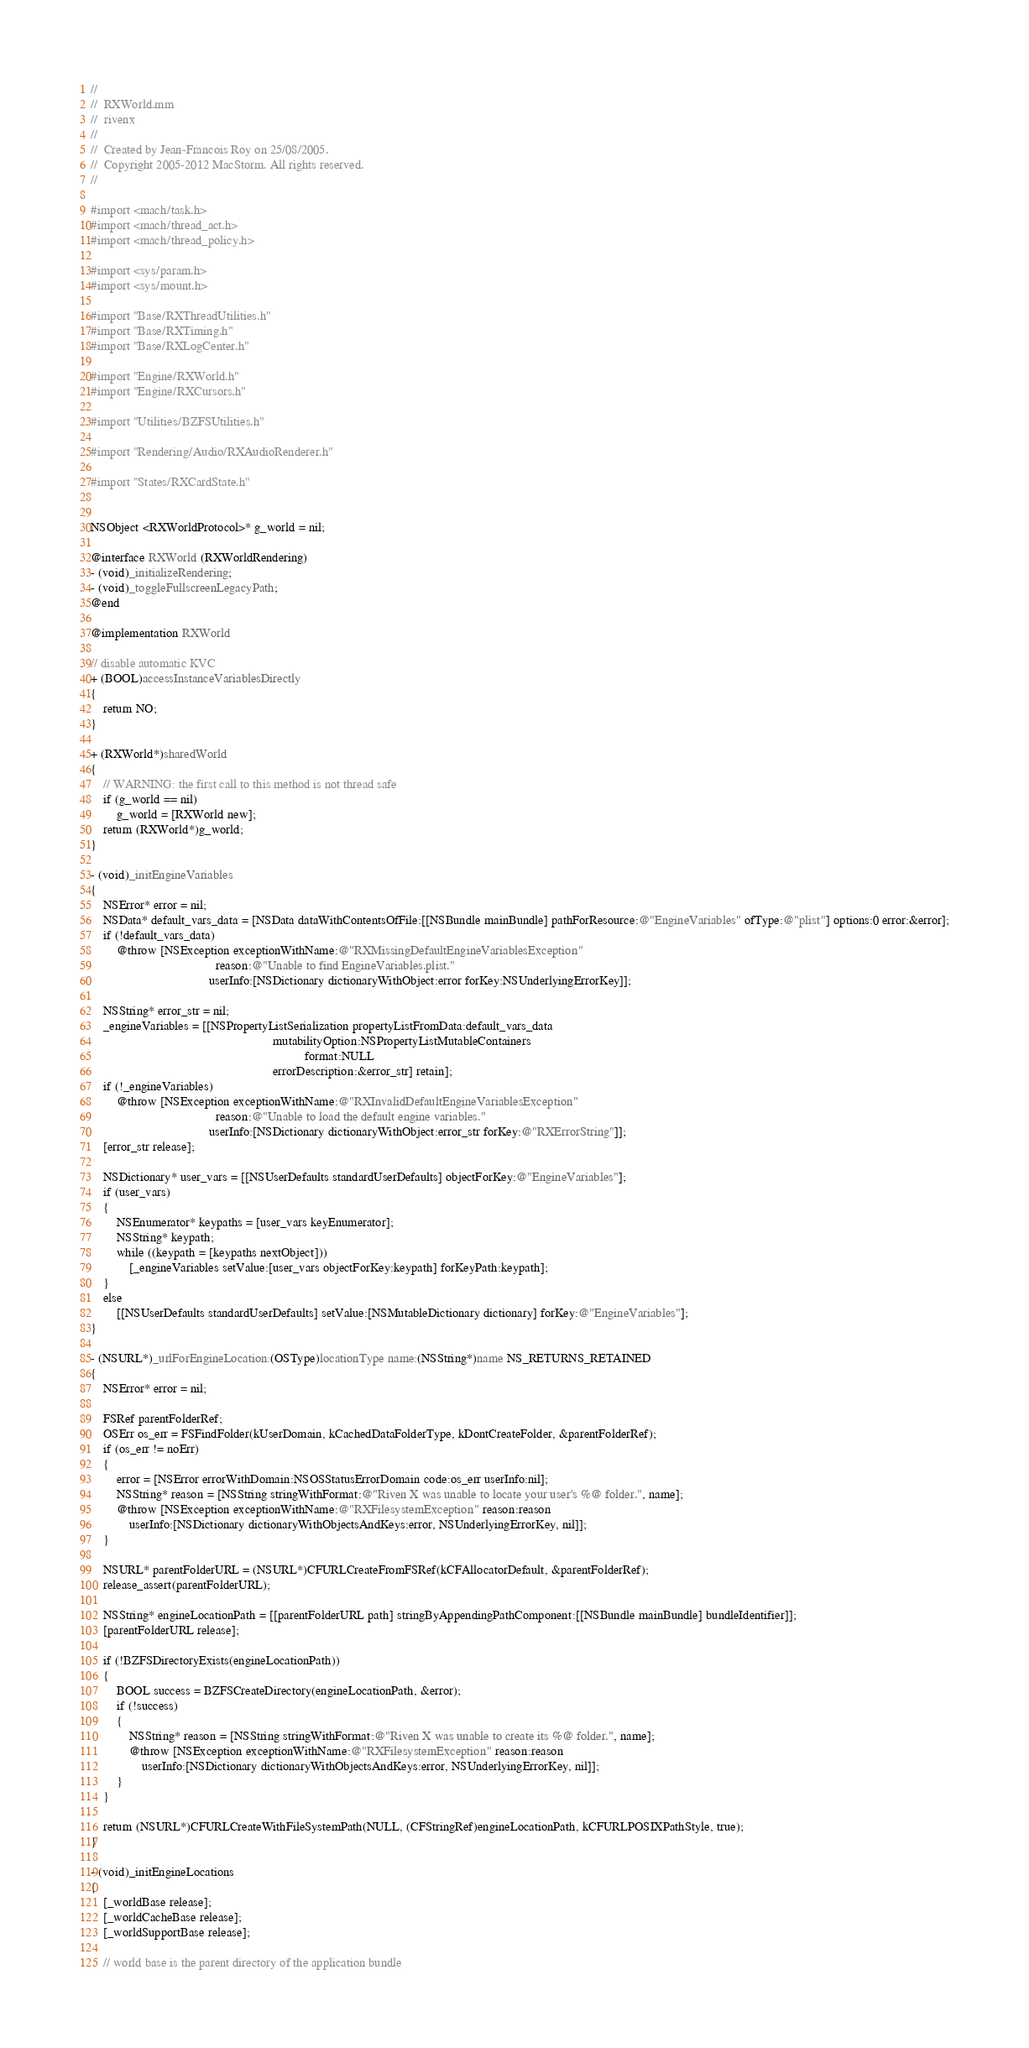<code> <loc_0><loc_0><loc_500><loc_500><_ObjectiveC_>//
//  RXWorld.mm
//  rivenx
//
//  Created by Jean-Francois Roy on 25/08/2005.
//  Copyright 2005-2012 MacStorm. All rights reserved.
//

#import <mach/task.h>
#import <mach/thread_act.h>
#import <mach/thread_policy.h>

#import <sys/param.h>
#import <sys/mount.h>

#import "Base/RXThreadUtilities.h"
#import "Base/RXTiming.h"
#import "Base/RXLogCenter.h"

#import "Engine/RXWorld.h"
#import "Engine/RXCursors.h"

#import "Utilities/BZFSUtilities.h"

#import "Rendering/Audio/RXAudioRenderer.h"

#import "States/RXCardState.h"


NSObject <RXWorldProtocol>* g_world = nil;

@interface RXWorld (RXWorldRendering)
- (void)_initializeRendering;
- (void)_toggleFullscreenLegacyPath;
@end

@implementation RXWorld

// disable automatic KVC
+ (BOOL)accessInstanceVariablesDirectly
{
    return NO;
}

+ (RXWorld*)sharedWorld
{
    // WARNING: the first call to this method is not thread safe
    if (g_world == nil)
        g_world = [RXWorld new];
    return (RXWorld*)g_world;
}

- (void)_initEngineVariables
{
    NSError* error = nil;
    NSData* default_vars_data = [NSData dataWithContentsOfFile:[[NSBundle mainBundle] pathForResource:@"EngineVariables" ofType:@"plist"] options:0 error:&error];
    if (!default_vars_data)
        @throw [NSException exceptionWithName:@"RXMissingDefaultEngineVariablesException"
                                       reason:@"Unable to find EngineVariables.plist."
                                     userInfo:[NSDictionary dictionaryWithObject:error forKey:NSUnderlyingErrorKey]];
    
    NSString* error_str = nil;
    _engineVariables = [[NSPropertyListSerialization propertyListFromData:default_vars_data
                                                         mutabilityOption:NSPropertyListMutableContainers
                                                                   format:NULL
                                                         errorDescription:&error_str] retain];
    if (!_engineVariables)
        @throw [NSException exceptionWithName:@"RXInvalidDefaultEngineVariablesException"
                                       reason:@"Unable to load the default engine variables."
                                     userInfo:[NSDictionary dictionaryWithObject:error_str forKey:@"RXErrorString"]];
    [error_str release];
    
    NSDictionary* user_vars = [[NSUserDefaults standardUserDefaults] objectForKey:@"EngineVariables"];
    if (user_vars)
    {
        NSEnumerator* keypaths = [user_vars keyEnumerator];
        NSString* keypath;
        while ((keypath = [keypaths nextObject]))
            [_engineVariables setValue:[user_vars objectForKey:keypath] forKeyPath:keypath];
    }
    else
        [[NSUserDefaults standardUserDefaults] setValue:[NSMutableDictionary dictionary] forKey:@"EngineVariables"];
}

- (NSURL*)_urlForEngineLocation:(OSType)locationType name:(NSString*)name NS_RETURNS_RETAINED
{
    NSError* error = nil;

    FSRef parentFolderRef;
    OSErr os_err = FSFindFolder(kUserDomain, kCachedDataFolderType, kDontCreateFolder, &parentFolderRef);
    if (os_err != noErr)
    {
        error = [NSError errorWithDomain:NSOSStatusErrorDomain code:os_err userInfo:nil];
        NSString* reason = [NSString stringWithFormat:@"Riven X was unable to locate your user's %@ folder.", name];
        @throw [NSException exceptionWithName:@"RXFilesystemException" reason:reason
            userInfo:[NSDictionary dictionaryWithObjectsAndKeys:error, NSUnderlyingErrorKey, nil]];
    }

    NSURL* parentFolderURL = (NSURL*)CFURLCreateFromFSRef(kCFAllocatorDefault, &parentFolderRef);
    release_assert(parentFolderURL);

    NSString* engineLocationPath = [[parentFolderURL path] stringByAppendingPathComponent:[[NSBundle mainBundle] bundleIdentifier]];
    [parentFolderURL release];

    if (!BZFSDirectoryExists(engineLocationPath))
    {
        BOOL success = BZFSCreateDirectory(engineLocationPath, &error);
        if (!success)
        {
            NSString* reason = [NSString stringWithFormat:@"Riven X was unable to create its %@ folder.", name];
            @throw [NSException exceptionWithName:@"RXFilesystemException" reason:reason
                userInfo:[NSDictionary dictionaryWithObjectsAndKeys:error, NSUnderlyingErrorKey, nil]];
        }
    }

    return (NSURL*)CFURLCreateWithFileSystemPath(NULL, (CFStringRef)engineLocationPath, kCFURLPOSIXPathStyle, true);
}

- (void)_initEngineLocations
{
    [_worldBase release];
    [_worldCacheBase release];
    [_worldSupportBase release];
    
    // world base is the parent directory of the application bundle</code> 